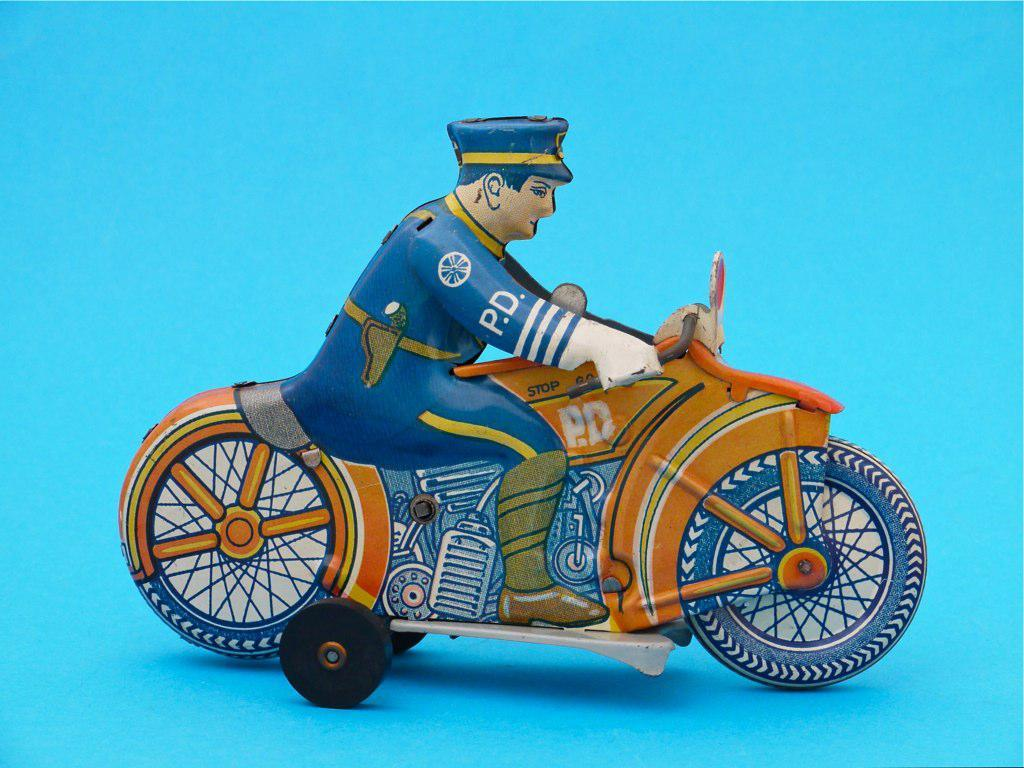What object is placed on a surface in the image? There is a toy placed on a surface in the image. What color is the background of the image? The background of the image is blue in color. What type of pleasure can be seen in the image? There is no indication of pleasure in the image; it simply shows a toy placed on a surface with a blue background. 